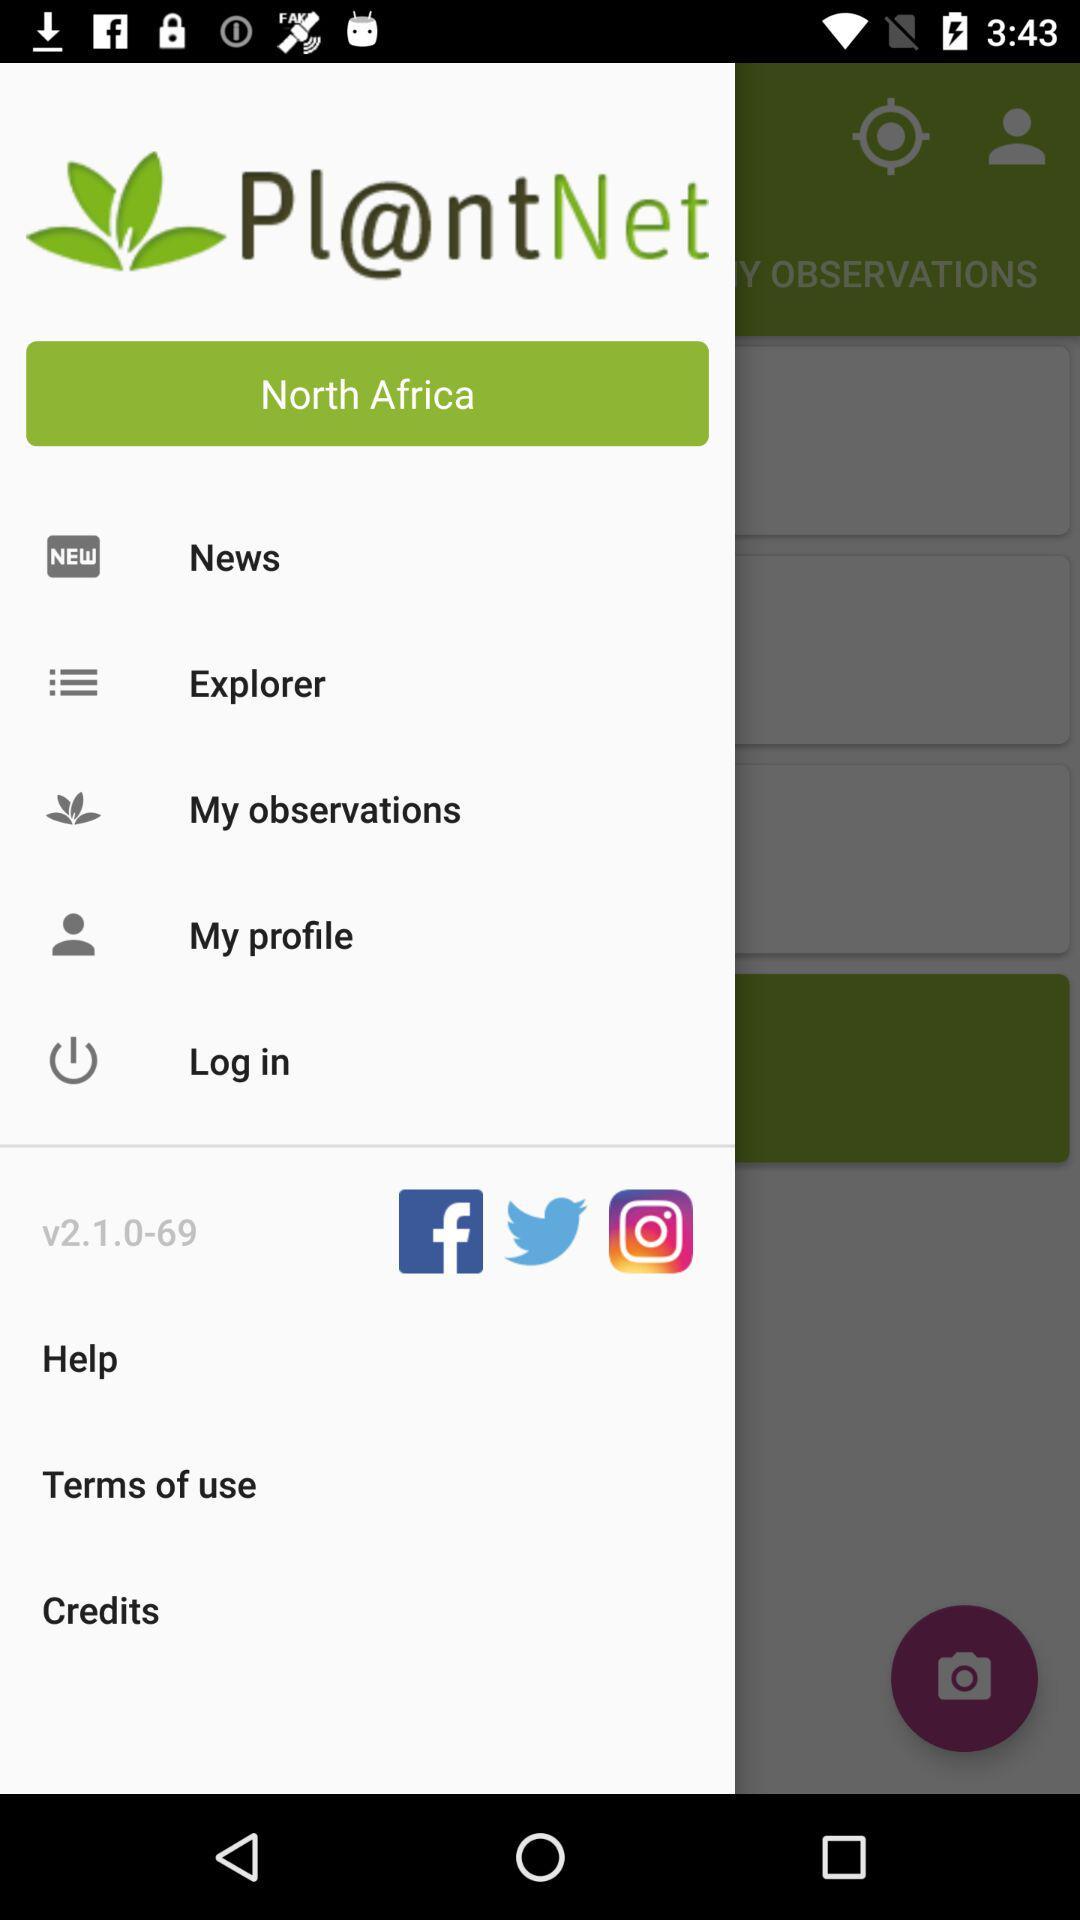What is the selected country? The selected country is North Africa. 